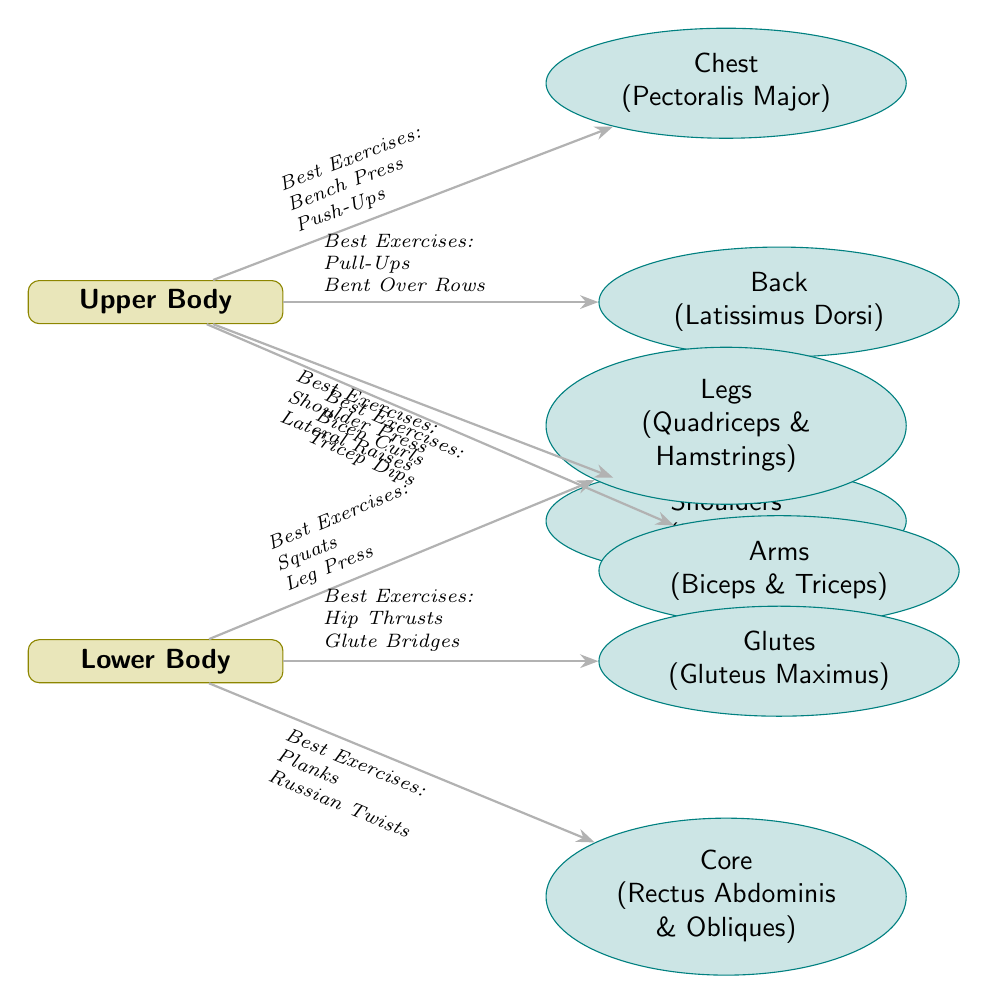What are the best exercises for the Chest? The diagram indicates that the best exercises for the Chest (Pectoralis Major) are Bench Press and Push-Ups.
Answer: Bench Press, Push-Ups How many main muscle groups are represented in this diagram? There are two main muscle groups represented: Upper Body and Lower Body.
Answer: 2 Which muscle group is associated with Hip Thrusts? The diagram connects Hip Thrusts to the Glutes (Gluteus Maximus) muscle group.
Answer: Glutes What are the best exercises for the Core? According to the diagram, the best exercises for the Core (Rectus Abdominis & Obliques) are Planks and Russian Twists.
Answer: Planks, Russian Twists Which muscle group does the Shoulder Press target? The diagram shows that the Shoulder Press targets the Shoulders (Deltoids) muscle group.
Answer: Shoulders How many subnodes are associated with the Upper Body? The Upper Body has four subnodes: Chest, Back, Shoulders, and Arms, making a total of four.
Answer: 4 If I want to work on my Biceps and Triceps, what exercise should I do? The diagram suggests performing Bicep Curls and Tricep Dips to work on Biceps and Triceps.
Answer: Bicep Curls, Tricep Dips What node represents the Gluteus Maximus? The Gluteus Maximus is represented by the Glutes node in the diagram.
Answer: Glutes What is the relationship between Arms and Shoulders in this diagram? Both Arms (Biceps & Triceps) and Shoulders (Deltoids) belong to the Upper Body group, indicating they are related as parts of the same broader category.
Answer: Related as parts of Upper Body 